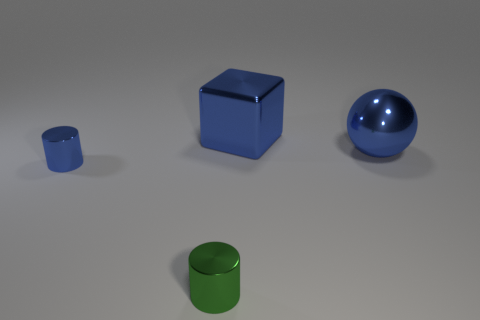Add 3 blue metal things. How many objects exist? 7 Subtract 2 cylinders. How many cylinders are left? 0 Subtract 0 cyan balls. How many objects are left? 4 Subtract all balls. How many objects are left? 3 Subtract all gray cubes. Subtract all cyan balls. How many cubes are left? 1 Subtract all purple blocks. How many blue cylinders are left? 1 Subtract all big blue metal things. Subtract all tiny gray shiny balls. How many objects are left? 2 Add 3 big blue metal spheres. How many big blue metal spheres are left? 4 Add 4 shiny cylinders. How many shiny cylinders exist? 6 